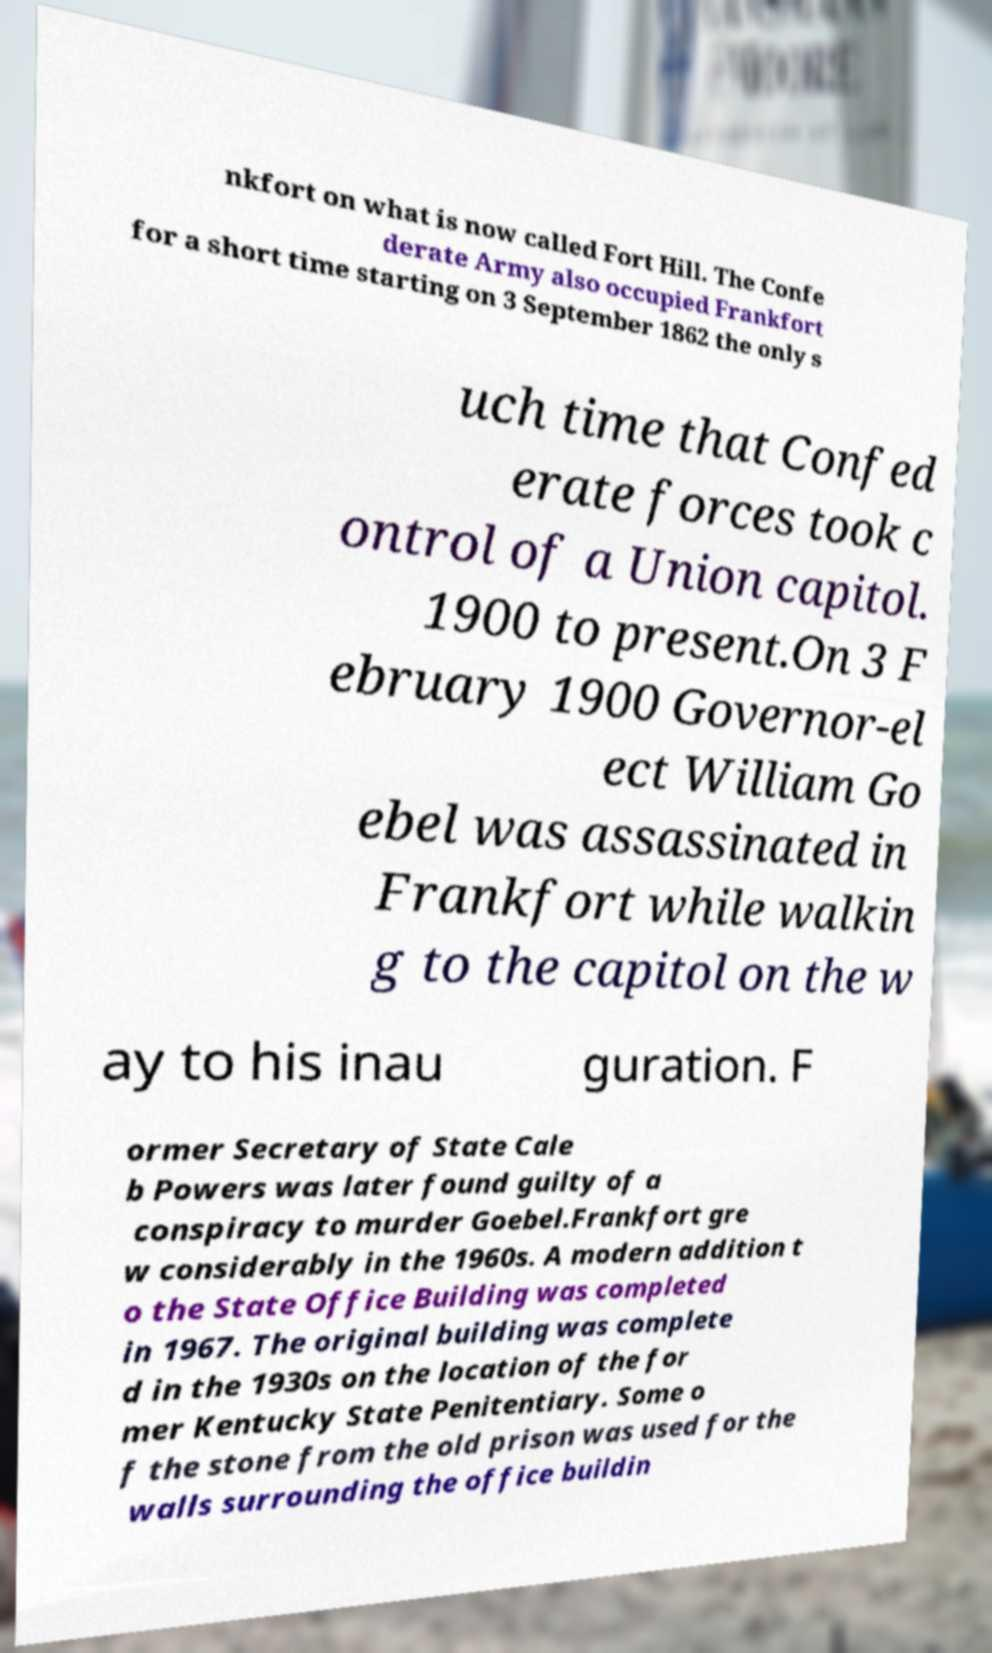There's text embedded in this image that I need extracted. Can you transcribe it verbatim? nkfort on what is now called Fort Hill. The Confe derate Army also occupied Frankfort for a short time starting on 3 September 1862 the only s uch time that Confed erate forces took c ontrol of a Union capitol. 1900 to present.On 3 F ebruary 1900 Governor-el ect William Go ebel was assassinated in Frankfort while walkin g to the capitol on the w ay to his inau guration. F ormer Secretary of State Cale b Powers was later found guilty of a conspiracy to murder Goebel.Frankfort gre w considerably in the 1960s. A modern addition t o the State Office Building was completed in 1967. The original building was complete d in the 1930s on the location of the for mer Kentucky State Penitentiary. Some o f the stone from the old prison was used for the walls surrounding the office buildin 